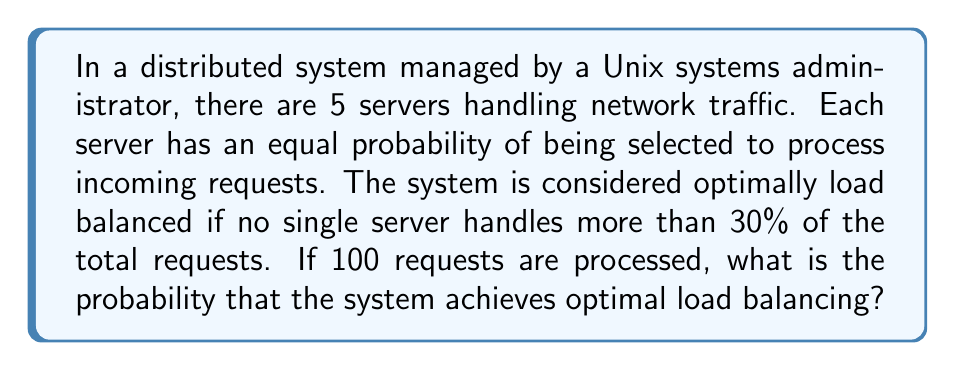Could you help me with this problem? Let's approach this step-by-step:

1) First, we need to understand what constitutes optimal load balancing. In this case, it means no server handles more than 30 requests out of 100.

2) This scenario follows a multinomial distribution, where we have 5 categories (servers) and 100 trials (requests).

3) The probability of a specific server being selected for each request is $p = \frac{1}{5} = 0.2$.

4) We need to calculate the probability that all servers handle 30 or fewer requests. This is equivalent to calculating 1 minus the probability that at least one server handles more than 30 requests.

5) The probability that at least one server handles more than 30 requests can be calculated using the inclusion-exclusion principle:

   $$P(\text{at least one server > 30}) = \binom{5}{1}P(X_1 > 30) - \binom{5}{2}P(X_1 > 30, X_2 > 30) + \binom{5}{3}P(X_1 > 30, X_2 > 30, X_3 > 30) - \binom{5}{4}P(X_1 > 30, X_2 > 30, X_3 > 30, X_4 > 30) + \binom{5}{5}P(X_1 > 30, X_2 > 30, X_3 > 30, X_4 > 30, X_5 > 30)$$

6) Each probability in this expression can be calculated using the binomial distribution:

   $$P(X_1 > 30) = \sum_{k=31}^{100} \binom{100}{k}(0.2)^k(0.8)^{100-k}$$

   $$P(X_1 > 30, X_2 > 30) = \sum_{k=31}^{69} \sum_{j=31}^{100-k} \binom{100}{k,j,100-k-j}(0.2)^k(0.2)^j(0.6)^{100-k-j}$$

   And so on for the other terms.

7) Calculating these probabilities:

   $P(X_1 > 30) \approx 0.0084$
   $P(X_1 > 30, X_2 > 30) \approx 1.4 \times 10^{-6}$
   $P(X_1 > 30, X_2 > 30, X_3 > 30) \approx 2.8 \times 10^{-11}$
   $P(X_1 > 30, X_2 > 30, X_3 > 30, X_4 > 30) \approx 5.6 \times 10^{-17}$
   $P(X_1 > 30, X_2 > 30, X_3 > 30, X_4 > 30, X_5 > 30) = 0$

8) Plugging these into the inclusion-exclusion formula:

   $$P(\text{at least one server > 30}) = 5(0.0084) - 10(1.4 \times 10^{-6}) + 10(2.8 \times 10^{-11}) - 5(5.6 \times 10^{-17}) + 0 \approx 0.0420$$

9) Therefore, the probability of optimal load balancing is:

   $$P(\text{optimal load balancing}) = 1 - P(\text{at least one server > 30}) \approx 1 - 0.0420 = 0.9580$$
Answer: $0.9580$ or $95.80\%$ 